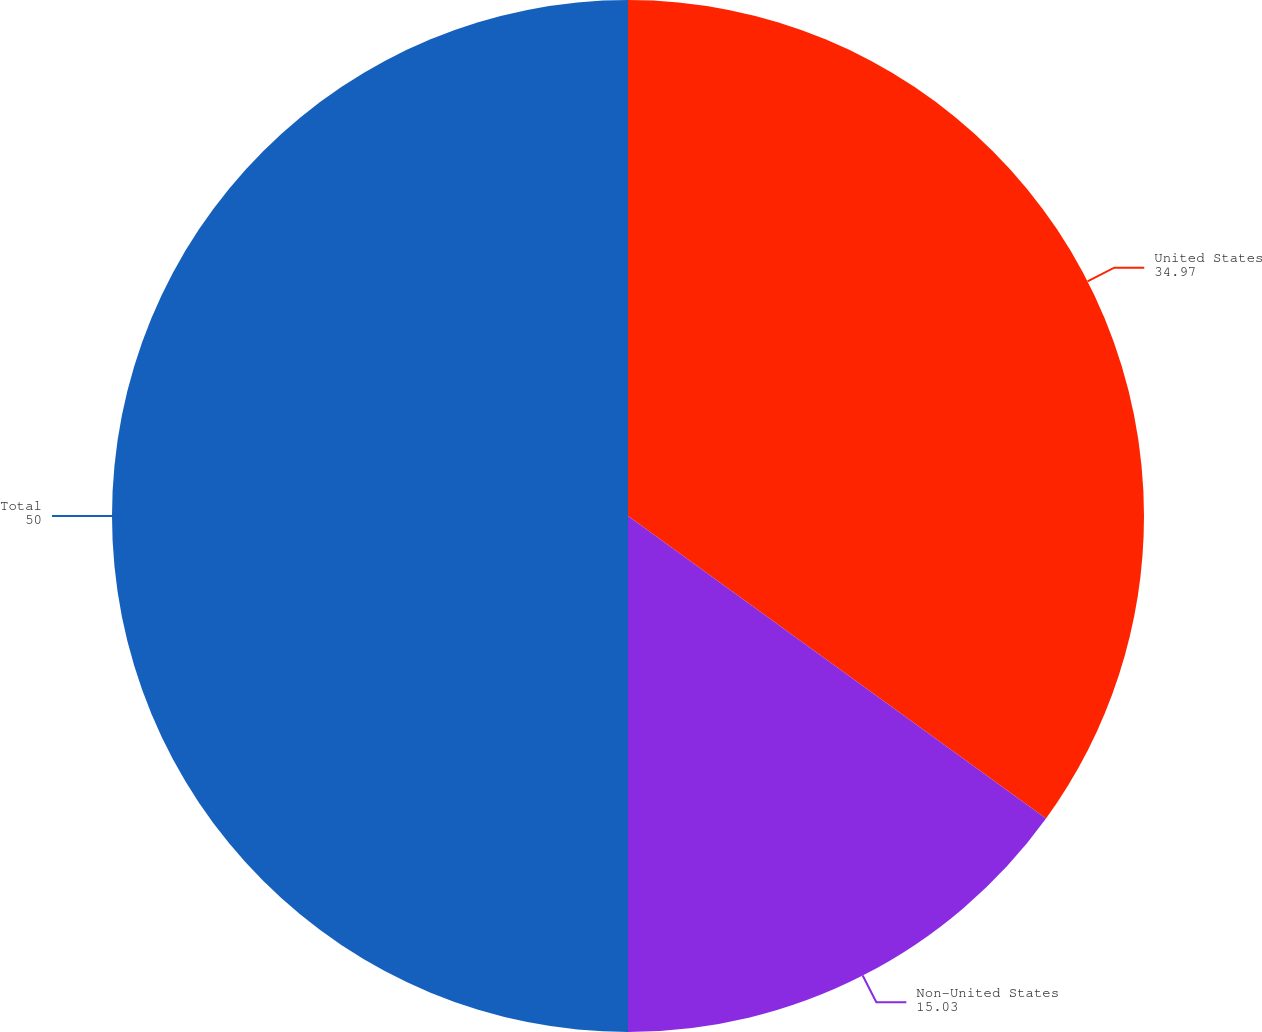Convert chart to OTSL. <chart><loc_0><loc_0><loc_500><loc_500><pie_chart><fcel>United States<fcel>Non-United States<fcel>Total<nl><fcel>34.97%<fcel>15.03%<fcel>50.0%<nl></chart> 